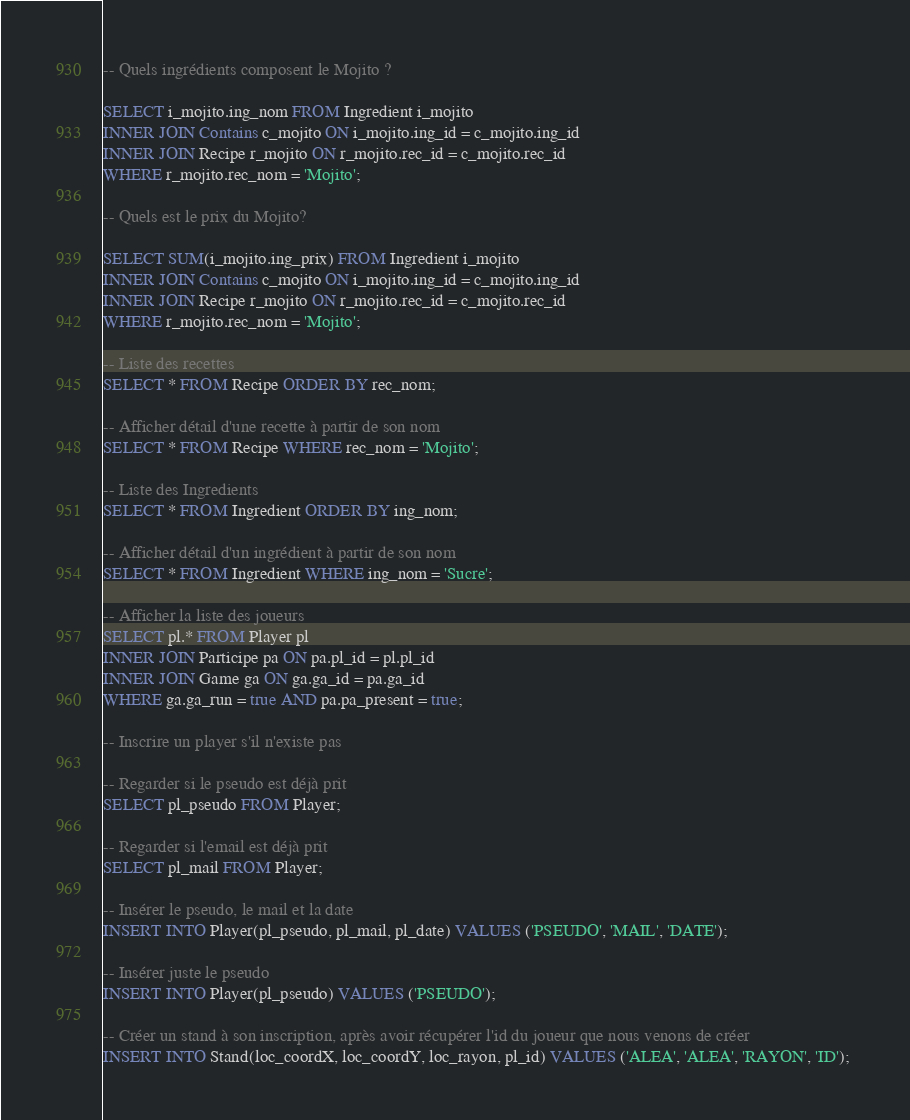Convert code to text. <code><loc_0><loc_0><loc_500><loc_500><_SQL_>-- Quels ingrédients composent le Mojito ?

SELECT i_mojito.ing_nom FROM Ingredient i_mojito
INNER JOIN Contains c_mojito ON i_mojito.ing_id = c_mojito.ing_id
INNER JOIN Recipe r_mojito ON r_mojito.rec_id = c_mojito.rec_id
WHERE r_mojito.rec_nom = 'Mojito'; 

-- Quels est le prix du Mojito?

SELECT SUM(i_mojito.ing_prix) FROM Ingredient i_mojito
INNER JOIN Contains c_mojito ON i_mojito.ing_id = c_mojito.ing_id
INNER JOIN Recipe r_mojito ON r_mojito.rec_id = c_mojito.rec_id
WHERE r_mojito.rec_nom = 'Mojito'; 

-- Liste des recettes
SELECT * FROM Recipe ORDER BY rec_nom;

-- Afficher détail d'une recette à partir de son nom
SELECT * FROM Recipe WHERE rec_nom = 'Mojito';

-- Liste des Ingredients 
SELECT * FROM Ingredient ORDER BY ing_nom;

-- Afficher détail d'un ingrédient à partir de son nom
SELECT * FROM Ingredient WHERE ing_nom = 'Sucre';

-- Afficher la liste des joueurs 
SELECT pl.* FROM Player pl
INNER JOIN Participe pa ON pa.pl_id = pl.pl_id
INNER JOIN Game ga ON ga.ga_id = pa.ga_id
WHERE ga.ga_run = true AND pa.pa_present = true; 

-- Inscrire un player s'il n'existe pas

-- Regarder si le pseudo est déjà prit
SELECT pl_pseudo FROM Player;

-- Regarder si l'email est déjà prit 
SELECT pl_mail FROM Player;

-- Insérer le pseudo, le mail et la date
INSERT INTO Player(pl_pseudo, pl_mail, pl_date) VALUES ('PSEUDO', 'MAIL', 'DATE');

-- Insérer juste le pseudo 
INSERT INTO Player(pl_pseudo) VALUES ('PSEUDO'); 

-- Créer un stand à son inscription, après avoir récupérer l'id du joueur que nous venons de créer
INSERT INTO Stand(loc_coordX, loc_coordY, loc_rayon, pl_id) VALUES ('ALEA', 'ALEA', 'RAYON', 'ID'); 



</code> 